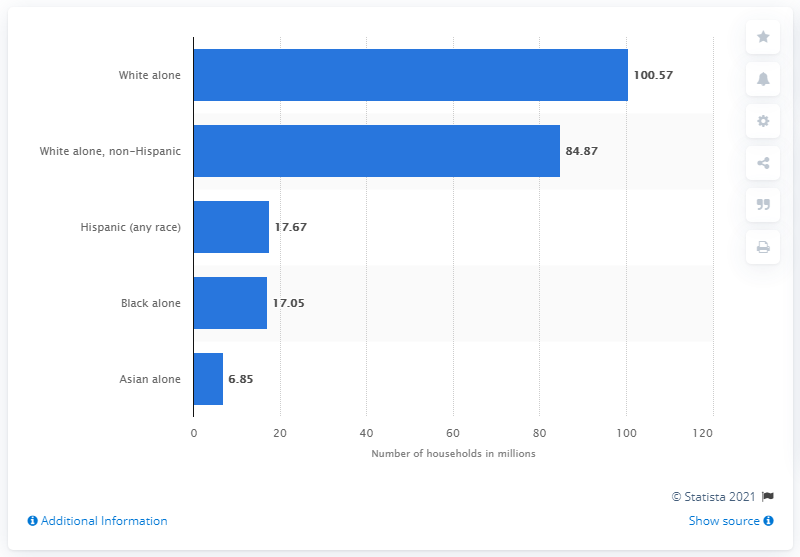Outline some significant characteristics in this image. In 2020, approximately 6.85% of households in the United States had an Asian background. 